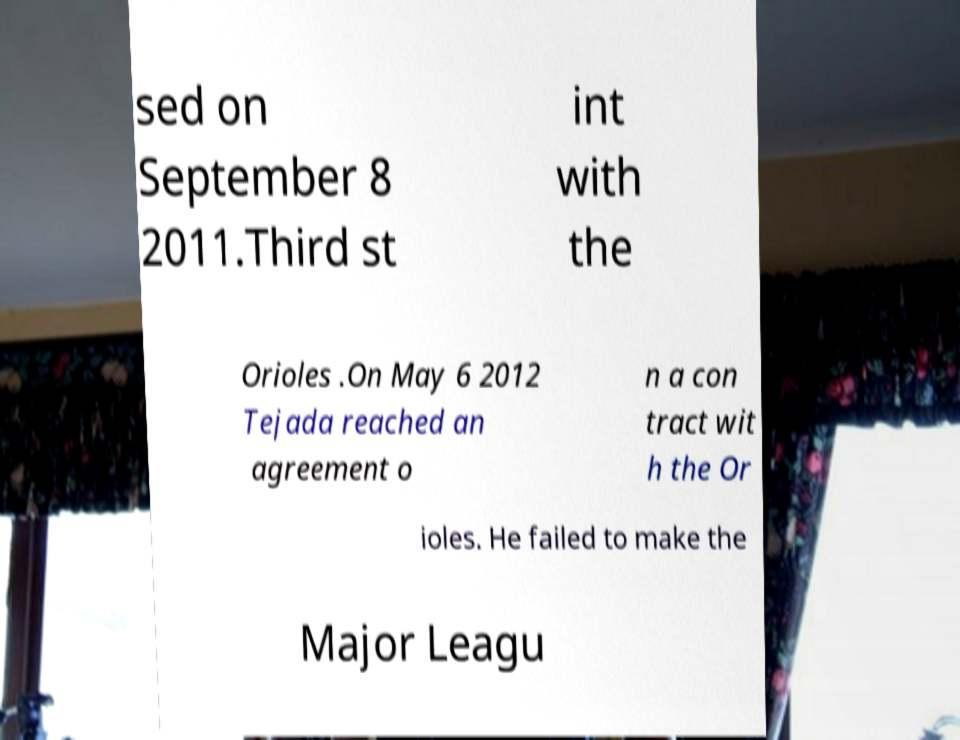Can you accurately transcribe the text from the provided image for me? sed on September 8 2011.Third st int with the Orioles .On May 6 2012 Tejada reached an agreement o n a con tract wit h the Or ioles. He failed to make the Major Leagu 